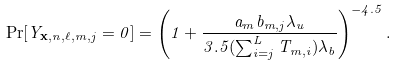Convert formula to latex. <formula><loc_0><loc_0><loc_500><loc_500>\Pr [ Y _ { \mathbf x , n , \ell , m , j } = 0 ] = \left ( 1 + \frac { a _ { m } b _ { m , j } \lambda _ { u } } { 3 . 5 ( \sum _ { i = j } ^ { L } T _ { m , i } ) \lambda _ { b } } \right ) ^ { - 4 . 5 } .</formula> 